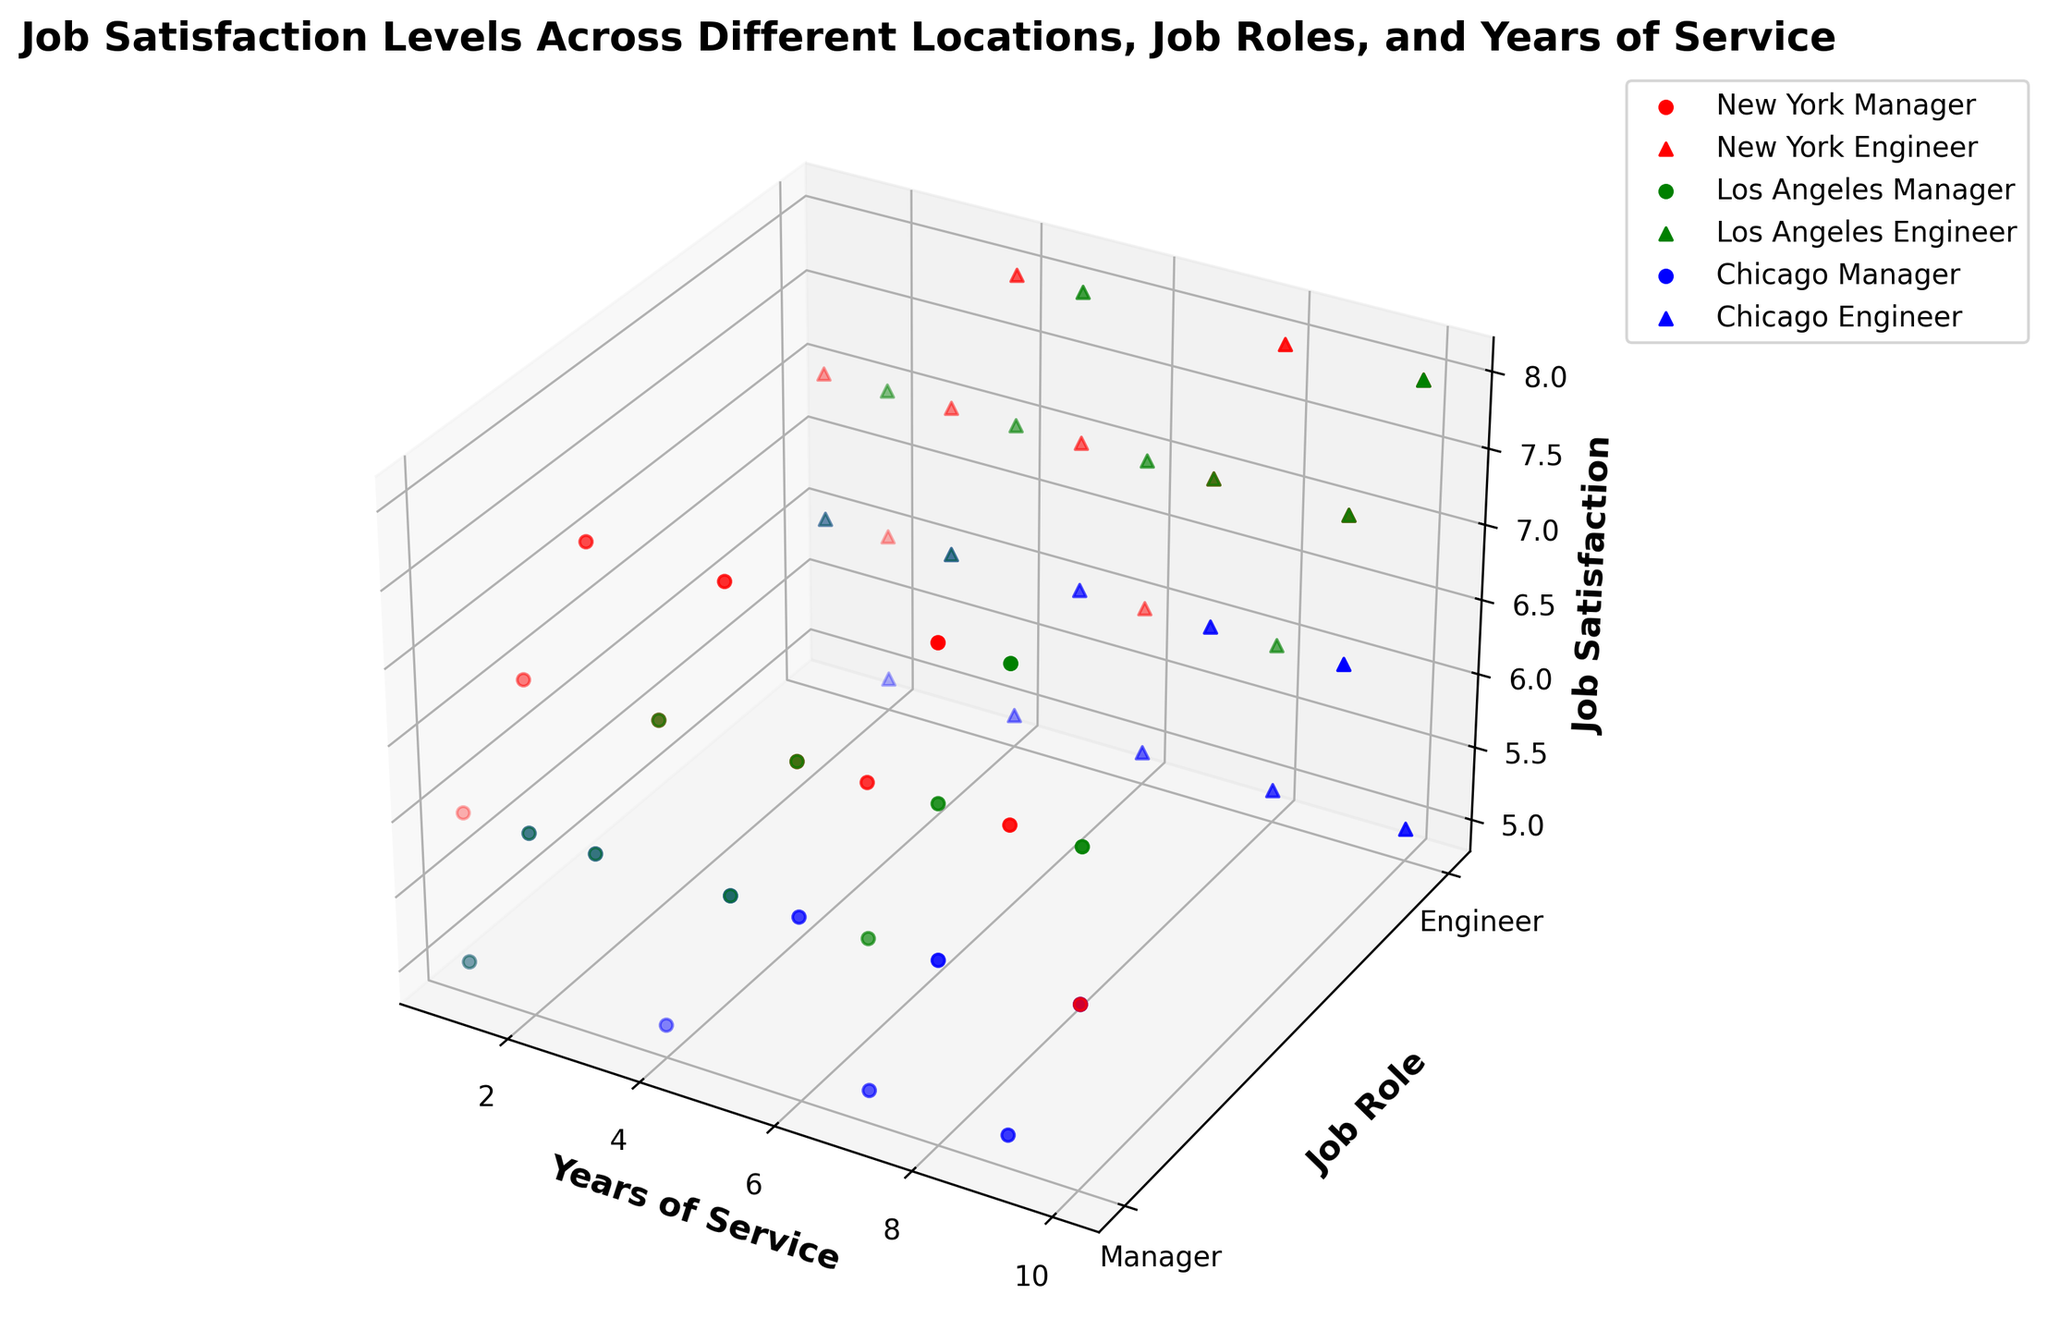Which location has the highest job satisfaction for Managers with 4 years of service? Look for the height of the points marked with circles ('o'), which represent 'Managers', and focus on the 4-year service mark along the X-axis. Compare New York (red), Los Angeles (green), and Chicago (blue). New York is the highest.
Answer: New York How does job satisfaction for Engineers in Los Angeles compare between 1 and 10 years of service? Look for the points marked with triangles ('^') in green, which represent 'Engineers' in Los Angeles, at 1 year and 10 years of service along the X-axis. The job satisfaction values are 6 and 8, respectively.
Answer: Satisfaction increased What is the average job satisfaction for Managers in New York across all years of service? Identify all the red circles ('o') that represent 'Managers' in New York and sum their Z-axis values: 6+7+8+7+8+7+7+8+7+6 = 71. The average over 10 points is 71/10.
Answer: 7.1 Is there a trend in job satisfaction over the years for Engineers in Chicago? Look for the points marked with blue triangles ('^'), which represent 'Engineers' in Chicago, and observe the pattern over the X-axis from 1 to 10 years. The Z-axis values show alternating satisfaction levels around 5-6, indicating no clear upward or downward trend.
Answer: No clear trend Which job role in Los Angeles shows a steadier increase in job satisfaction over the years? Compare green points for 'Managers' (circles) and 'Engineers' (triangles) over the X-axis years. Managers have more consistent values, while Engineers fluctuate.
Answer: Managers Do Managers in Chicago generally have higher or lower job satisfaction compared to Engineers in Chicago? Compare blue circles ('Managers') and blue triangles ('Engineers'). Most points are around 5-6, but Managers slightly edge Engineers in terms of slightly higher values.
Answer: Managers slightly higher Compare the job satisfaction for Engineers with 5 years of service across all locations. Look for all points at the 5-year mark on the X-axis for Engineers ('^'): New York (7), Los Angeles (8), and Chicago (6).
Answer: Los Angeles highest, then New York, then Chicago Is there any location where Managers and Engineers have roughly the same job satisfaction levels? Compare pairs of circles ('o') and triangles ('^'). In Chicago (blue), both roles have similar values around 5-6 over all years.
Answer: Chicago What is the difference in job satisfaction between Engineers and Managers in New York at 8 years of service? Find the job satisfaction values for both roles at the 8-year mark in New York (red): Manager is 8, Engineer is 8. Difference is 0.
Answer: 0 